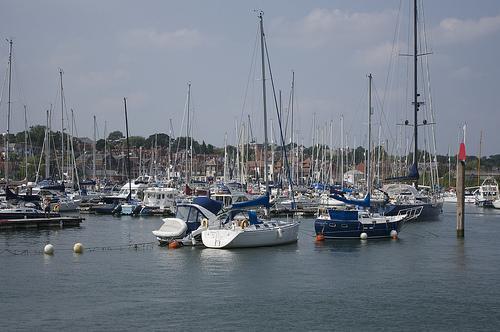How many red flags are shown?
Give a very brief answer. 1. 